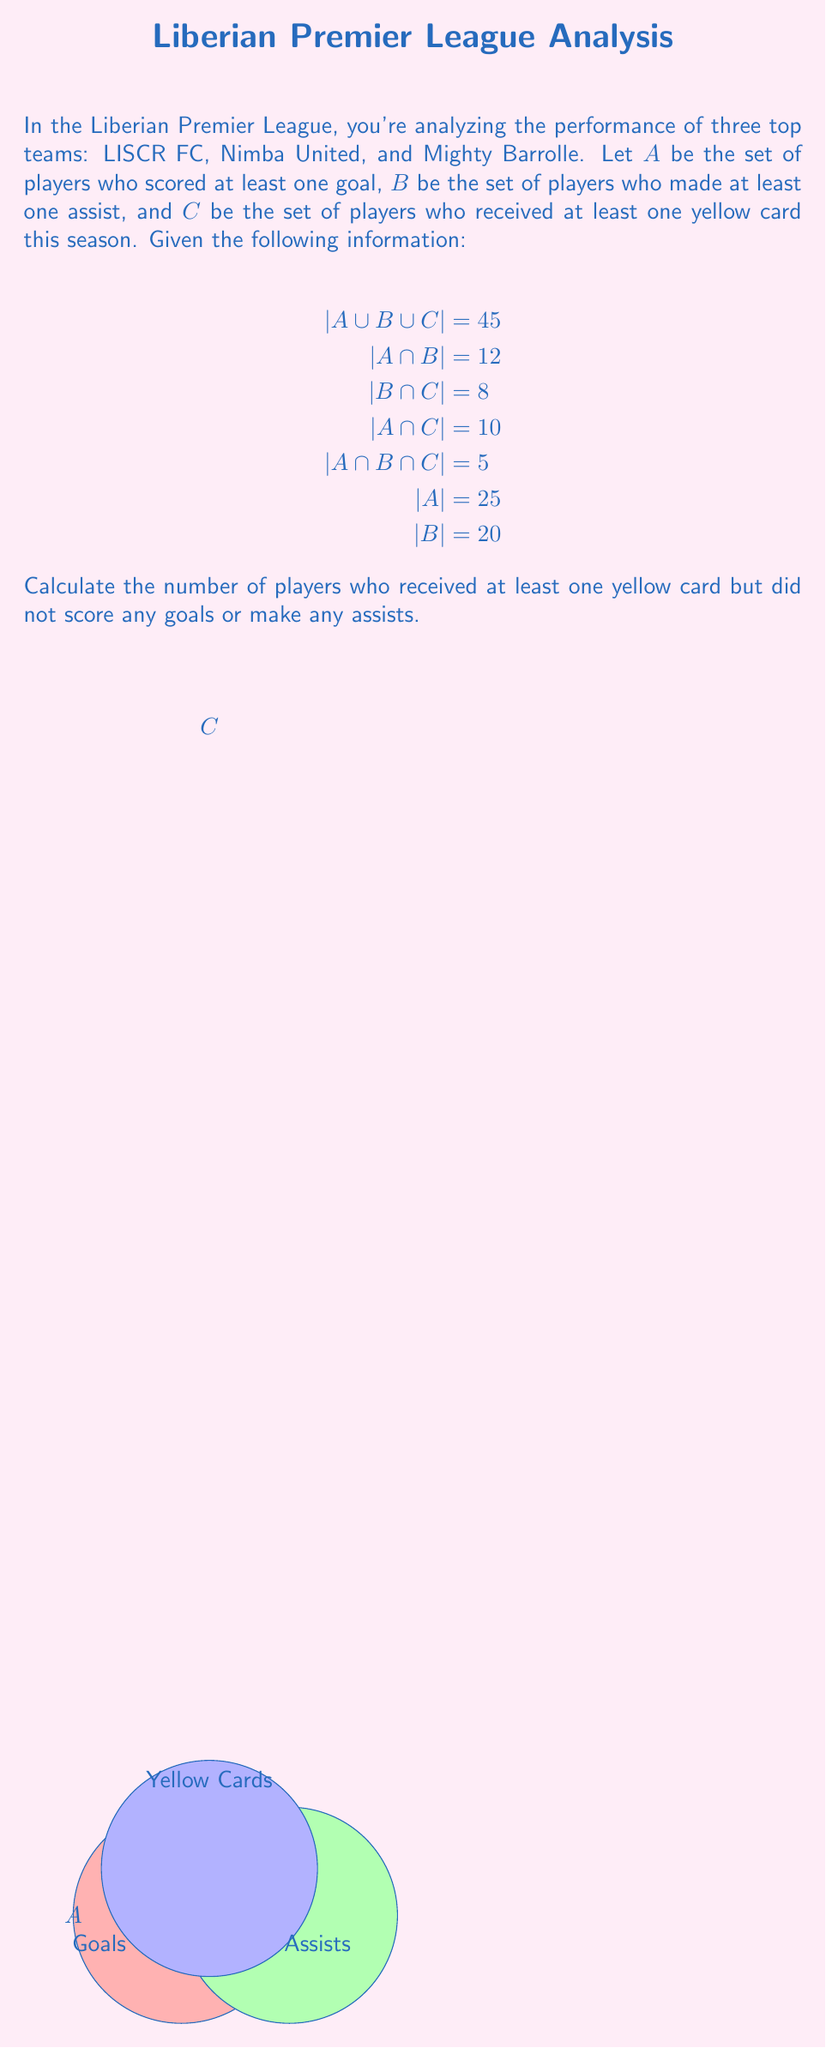Could you help me with this problem? Let's approach this step-by-step using set theory:

1) First, we need to find $|C|$. We can use the inclusion-exclusion principle:

   $$|A \cup B \cup C| = |A| + |B| + |C| - |A \cap B| - |A \cap C| - |B \cap C| + |A \cap B \cap C|$$

2) Substituting the known values:

   $$45 = 25 + 20 + |C| - 12 - 10 - 8 + 5$$

3) Solving for $|C|$:

   $$|C| = 45 - 25 - 20 + 12 + 10 + 8 - 5 = 25$$

4) Now, we need to find $|C - (A \cup B)|$, which represents players who received a yellow card but didn't score or assist.

5) We can use the formula: $|C - (A \cup B)| = |C| - |C \cap (A \cup B)|$

6) To find $|C \cap (A \cup B)|$, we can use:
   
   $$|C \cap (A \cup B)| = |C \cap A| + |C \cap B| - |C \cap A \cap B|$$

7) We know $|C \cap A| = 10$ and $|C \cap B| = 8$. $|C \cap A \cap B|$ is the same as $|A \cap B \cap C| = 5$.

8) So, $|C \cap (A \cup B)| = 10 + 8 - 5 = 13$

9) Finally, $|C - (A \cup B)| = |C| - |C \cap (A \cup B)| = 25 - 13 = 12$

Therefore, 12 players received at least one yellow card but did not score any goals or make any assists.
Answer: 12 players 